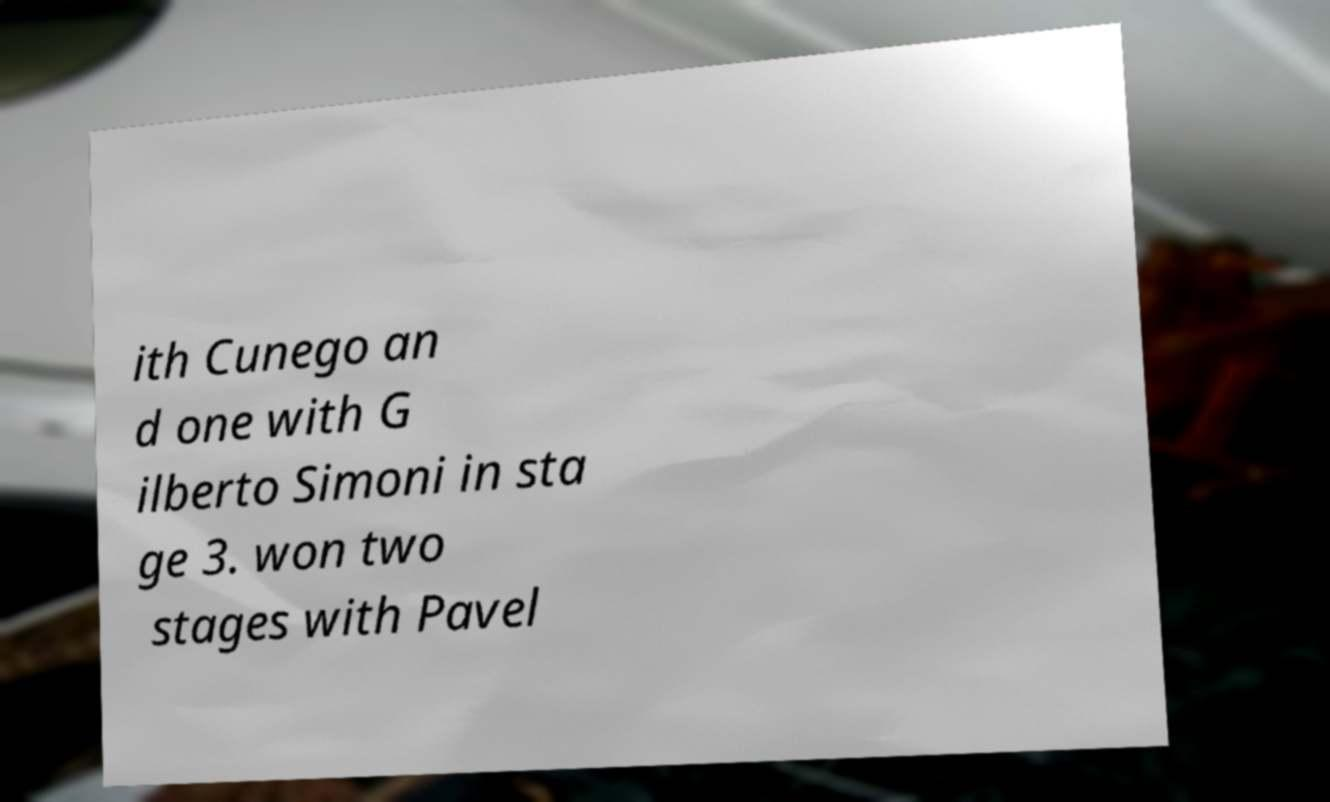Could you assist in decoding the text presented in this image and type it out clearly? ith Cunego an d one with G ilberto Simoni in sta ge 3. won two stages with Pavel 